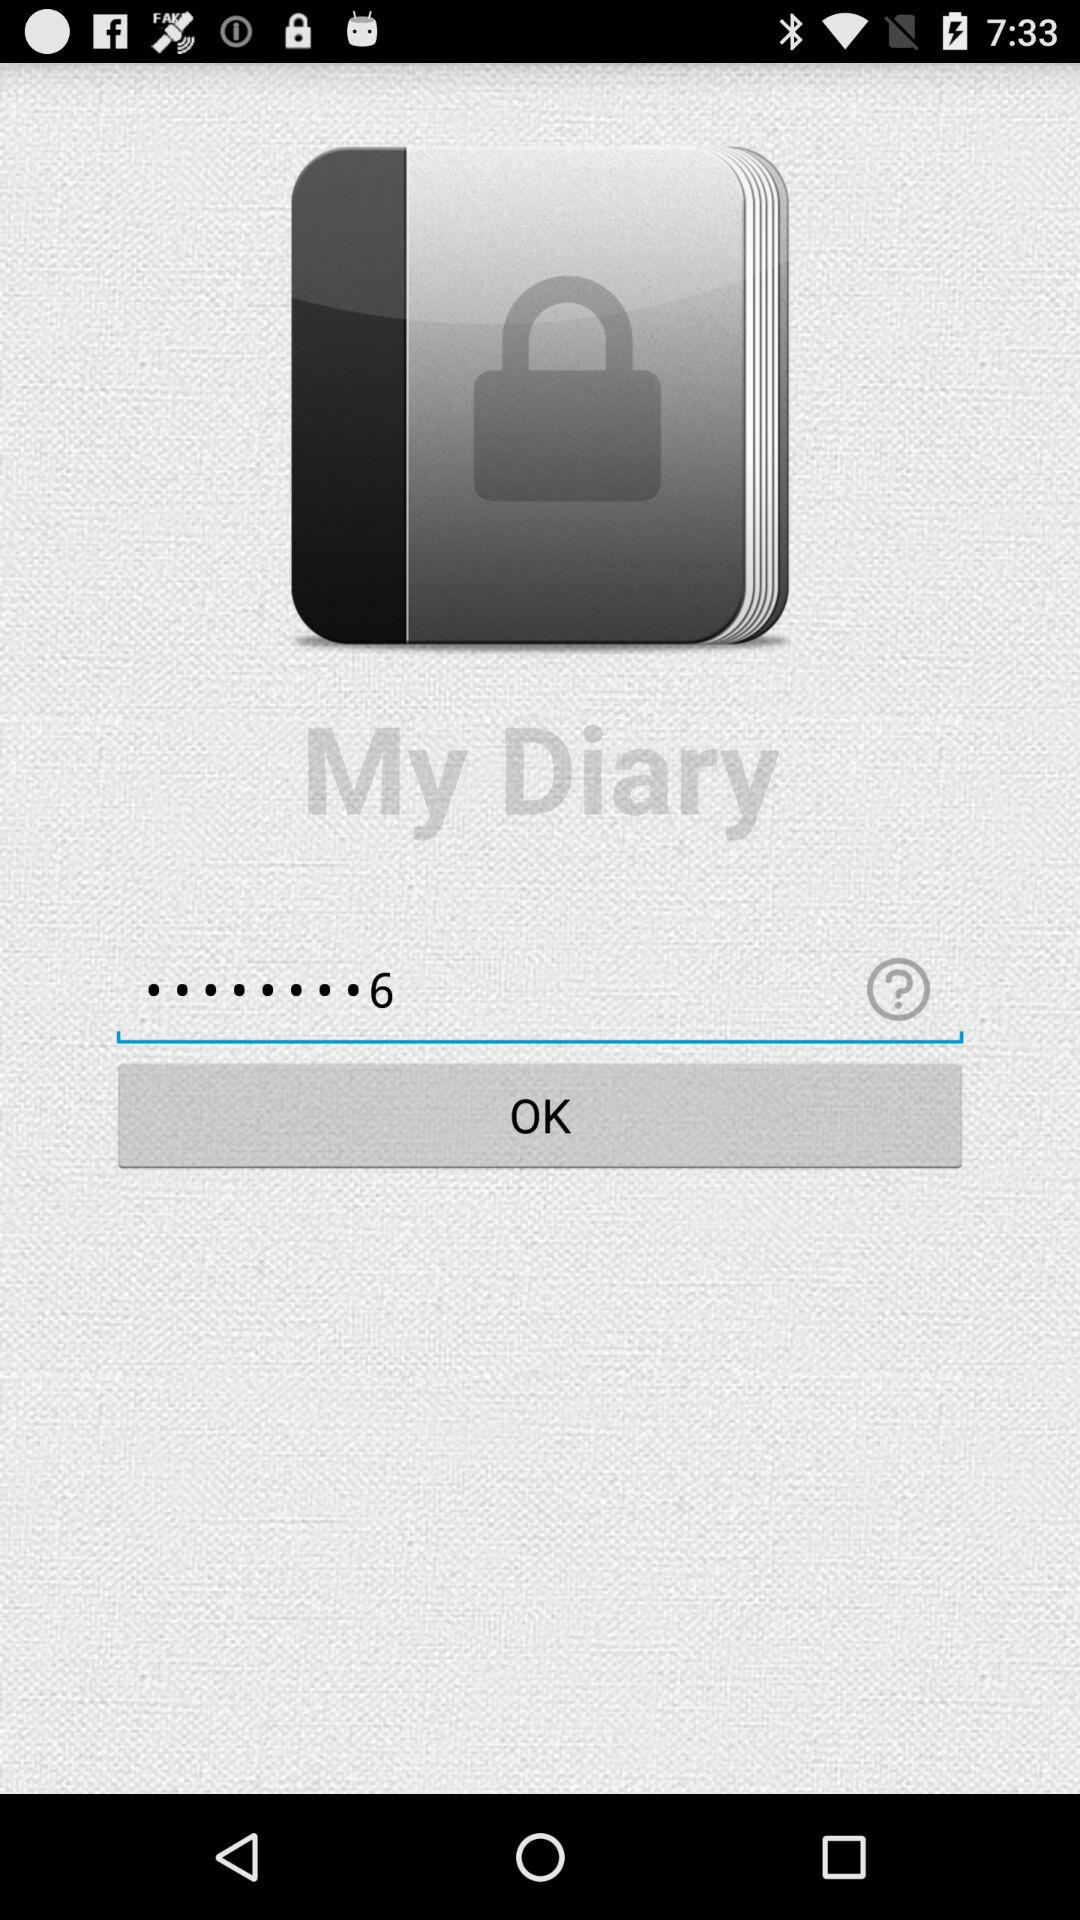What is the name of the application? The name of the application is "My Diary". 